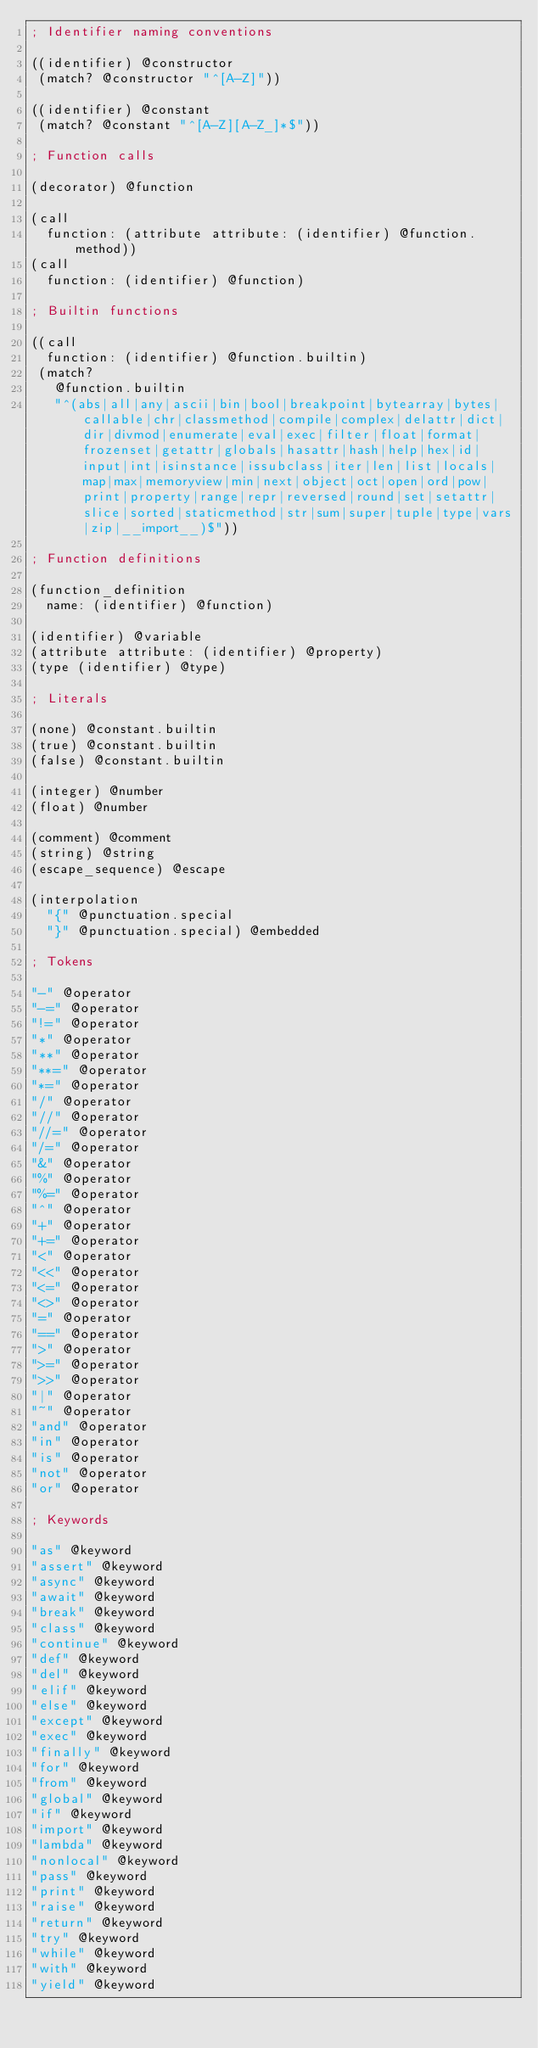<code> <loc_0><loc_0><loc_500><loc_500><_Scheme_>; Identifier naming conventions

((identifier) @constructor
 (match? @constructor "^[A-Z]"))

((identifier) @constant
 (match? @constant "^[A-Z][A-Z_]*$"))

; Function calls

(decorator) @function

(call
  function: (attribute attribute: (identifier) @function.method))
(call
  function: (identifier) @function)

; Builtin functions

((call
  function: (identifier) @function.builtin)
 (match?
   @function.builtin
   "^(abs|all|any|ascii|bin|bool|breakpoint|bytearray|bytes|callable|chr|classmethod|compile|complex|delattr|dict|dir|divmod|enumerate|eval|exec|filter|float|format|frozenset|getattr|globals|hasattr|hash|help|hex|id|input|int|isinstance|issubclass|iter|len|list|locals|map|max|memoryview|min|next|object|oct|open|ord|pow|print|property|range|repr|reversed|round|set|setattr|slice|sorted|staticmethod|str|sum|super|tuple|type|vars|zip|__import__)$"))

; Function definitions

(function_definition
  name: (identifier) @function)

(identifier) @variable
(attribute attribute: (identifier) @property)
(type (identifier) @type)

; Literals

(none) @constant.builtin
(true) @constant.builtin
(false) @constant.builtin

(integer) @number
(float) @number

(comment) @comment
(string) @string
(escape_sequence) @escape

(interpolation
  "{" @punctuation.special
  "}" @punctuation.special) @embedded

; Tokens

"-" @operator
"-=" @operator
"!=" @operator
"*" @operator
"**" @operator
"**=" @operator
"*=" @operator
"/" @operator
"//" @operator
"//=" @operator
"/=" @operator
"&" @operator
"%" @operator
"%=" @operator
"^" @operator
"+" @operator
"+=" @operator
"<" @operator
"<<" @operator
"<=" @operator
"<>" @operator
"=" @operator
"==" @operator
">" @operator
">=" @operator
">>" @operator
"|" @operator
"~" @operator
"and" @operator
"in" @operator
"is" @operator
"not" @operator
"or" @operator

; Keywords

"as" @keyword
"assert" @keyword
"async" @keyword
"await" @keyword
"break" @keyword
"class" @keyword
"continue" @keyword
"def" @keyword
"del" @keyword
"elif" @keyword
"else" @keyword
"except" @keyword
"exec" @keyword
"finally" @keyword
"for" @keyword
"from" @keyword
"global" @keyword
"if" @keyword
"import" @keyword
"lambda" @keyword
"nonlocal" @keyword
"pass" @keyword
"print" @keyword
"raise" @keyword
"return" @keyword
"try" @keyword
"while" @keyword
"with" @keyword
"yield" @keyword
</code> 